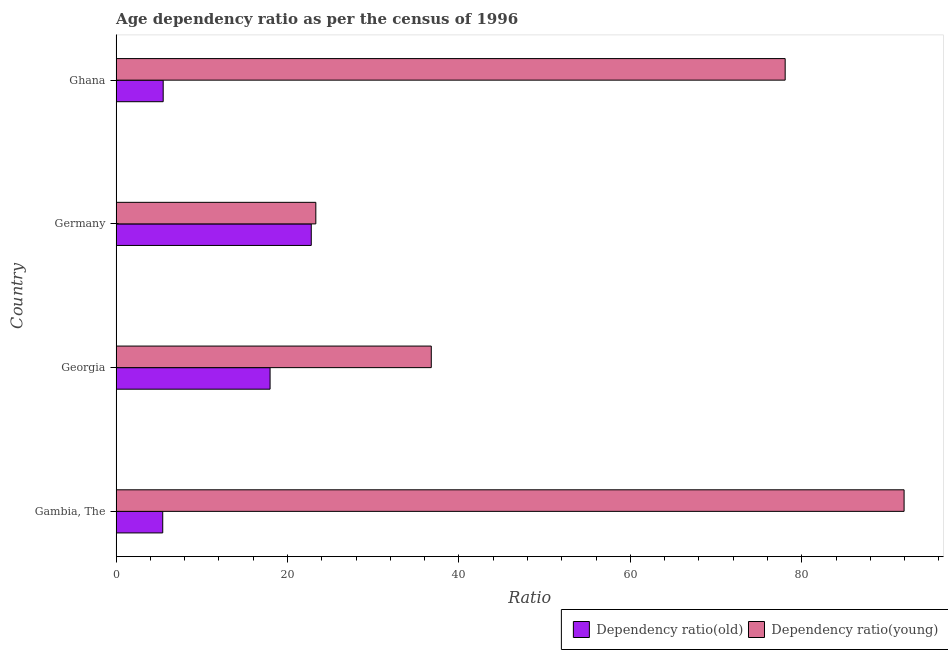How many groups of bars are there?
Provide a short and direct response. 4. Are the number of bars per tick equal to the number of legend labels?
Offer a terse response. Yes. Are the number of bars on each tick of the Y-axis equal?
Offer a very short reply. Yes. How many bars are there on the 2nd tick from the top?
Your response must be concise. 2. What is the label of the 4th group of bars from the top?
Ensure brevity in your answer.  Gambia, The. In how many cases, is the number of bars for a given country not equal to the number of legend labels?
Your response must be concise. 0. What is the age dependency ratio(old) in Ghana?
Your answer should be very brief. 5.49. Across all countries, what is the maximum age dependency ratio(old)?
Ensure brevity in your answer.  22.77. Across all countries, what is the minimum age dependency ratio(young)?
Your response must be concise. 23.3. In which country was the age dependency ratio(old) maximum?
Provide a short and direct response. Germany. In which country was the age dependency ratio(old) minimum?
Offer a very short reply. Gambia, The. What is the total age dependency ratio(young) in the graph?
Your response must be concise. 230.05. What is the difference between the age dependency ratio(old) in Gambia, The and that in Ghana?
Offer a very short reply. -0.05. What is the difference between the age dependency ratio(old) in Gambia, The and the age dependency ratio(young) in Germany?
Your response must be concise. -17.86. What is the average age dependency ratio(old) per country?
Offer a terse response. 12.91. What is the difference between the age dependency ratio(old) and age dependency ratio(young) in Germany?
Your response must be concise. -0.53. In how many countries, is the age dependency ratio(young) greater than 60 ?
Provide a short and direct response. 2. What is the ratio of the age dependency ratio(young) in Germany to that in Ghana?
Offer a terse response. 0.3. What is the difference between the highest and the second highest age dependency ratio(young)?
Your answer should be very brief. 13.87. What is the difference between the highest and the lowest age dependency ratio(old)?
Your answer should be very brief. 17.33. Is the sum of the age dependency ratio(old) in Germany and Ghana greater than the maximum age dependency ratio(young) across all countries?
Keep it short and to the point. No. What does the 2nd bar from the top in Ghana represents?
Provide a succinct answer. Dependency ratio(old). What does the 1st bar from the bottom in Gambia, The represents?
Your answer should be very brief. Dependency ratio(old). Are all the bars in the graph horizontal?
Give a very brief answer. Yes. What is the difference between two consecutive major ticks on the X-axis?
Keep it short and to the point. 20. Are the values on the major ticks of X-axis written in scientific E-notation?
Keep it short and to the point. No. Does the graph contain grids?
Provide a succinct answer. No. Where does the legend appear in the graph?
Your response must be concise. Bottom right. How many legend labels are there?
Provide a short and direct response. 2. What is the title of the graph?
Give a very brief answer. Age dependency ratio as per the census of 1996. Does "GDP per capita" appear as one of the legend labels in the graph?
Your answer should be very brief. No. What is the label or title of the X-axis?
Offer a very short reply. Ratio. What is the Ratio in Dependency ratio(old) in Gambia, The?
Provide a succinct answer. 5.44. What is the Ratio of Dependency ratio(young) in Gambia, The?
Your response must be concise. 91.93. What is the Ratio of Dependency ratio(old) in Georgia?
Offer a very short reply. 17.96. What is the Ratio in Dependency ratio(young) in Georgia?
Offer a terse response. 36.77. What is the Ratio of Dependency ratio(old) in Germany?
Your answer should be very brief. 22.77. What is the Ratio of Dependency ratio(young) in Germany?
Offer a terse response. 23.3. What is the Ratio of Dependency ratio(old) in Ghana?
Your answer should be very brief. 5.49. What is the Ratio in Dependency ratio(young) in Ghana?
Provide a short and direct response. 78.06. Across all countries, what is the maximum Ratio in Dependency ratio(old)?
Make the answer very short. 22.77. Across all countries, what is the maximum Ratio in Dependency ratio(young)?
Your answer should be very brief. 91.93. Across all countries, what is the minimum Ratio in Dependency ratio(old)?
Offer a terse response. 5.44. Across all countries, what is the minimum Ratio of Dependency ratio(young)?
Give a very brief answer. 23.3. What is the total Ratio of Dependency ratio(old) in the graph?
Your answer should be very brief. 51.66. What is the total Ratio of Dependency ratio(young) in the graph?
Offer a very short reply. 230.05. What is the difference between the Ratio of Dependency ratio(old) in Gambia, The and that in Georgia?
Provide a short and direct response. -12.52. What is the difference between the Ratio of Dependency ratio(young) in Gambia, The and that in Georgia?
Provide a short and direct response. 55.16. What is the difference between the Ratio in Dependency ratio(old) in Gambia, The and that in Germany?
Give a very brief answer. -17.33. What is the difference between the Ratio in Dependency ratio(young) in Gambia, The and that in Germany?
Provide a short and direct response. 68.63. What is the difference between the Ratio in Dependency ratio(old) in Gambia, The and that in Ghana?
Provide a succinct answer. -0.05. What is the difference between the Ratio in Dependency ratio(young) in Gambia, The and that in Ghana?
Provide a short and direct response. 13.87. What is the difference between the Ratio of Dependency ratio(old) in Georgia and that in Germany?
Give a very brief answer. -4.8. What is the difference between the Ratio in Dependency ratio(young) in Georgia and that in Germany?
Your answer should be very brief. 13.47. What is the difference between the Ratio in Dependency ratio(old) in Georgia and that in Ghana?
Offer a terse response. 12.47. What is the difference between the Ratio in Dependency ratio(young) in Georgia and that in Ghana?
Offer a very short reply. -41.29. What is the difference between the Ratio in Dependency ratio(old) in Germany and that in Ghana?
Offer a very short reply. 17.27. What is the difference between the Ratio of Dependency ratio(young) in Germany and that in Ghana?
Your answer should be compact. -54.76. What is the difference between the Ratio of Dependency ratio(old) in Gambia, The and the Ratio of Dependency ratio(young) in Georgia?
Keep it short and to the point. -31.33. What is the difference between the Ratio of Dependency ratio(old) in Gambia, The and the Ratio of Dependency ratio(young) in Germany?
Offer a terse response. -17.86. What is the difference between the Ratio of Dependency ratio(old) in Gambia, The and the Ratio of Dependency ratio(young) in Ghana?
Provide a succinct answer. -72.62. What is the difference between the Ratio in Dependency ratio(old) in Georgia and the Ratio in Dependency ratio(young) in Germany?
Offer a very short reply. -5.34. What is the difference between the Ratio in Dependency ratio(old) in Georgia and the Ratio in Dependency ratio(young) in Ghana?
Your answer should be very brief. -60.09. What is the difference between the Ratio of Dependency ratio(old) in Germany and the Ratio of Dependency ratio(young) in Ghana?
Your response must be concise. -55.29. What is the average Ratio in Dependency ratio(old) per country?
Give a very brief answer. 12.91. What is the average Ratio in Dependency ratio(young) per country?
Make the answer very short. 57.51. What is the difference between the Ratio of Dependency ratio(old) and Ratio of Dependency ratio(young) in Gambia, The?
Make the answer very short. -86.49. What is the difference between the Ratio of Dependency ratio(old) and Ratio of Dependency ratio(young) in Georgia?
Provide a succinct answer. -18.81. What is the difference between the Ratio in Dependency ratio(old) and Ratio in Dependency ratio(young) in Germany?
Ensure brevity in your answer.  -0.53. What is the difference between the Ratio of Dependency ratio(old) and Ratio of Dependency ratio(young) in Ghana?
Offer a terse response. -72.57. What is the ratio of the Ratio in Dependency ratio(old) in Gambia, The to that in Georgia?
Your response must be concise. 0.3. What is the ratio of the Ratio in Dependency ratio(young) in Gambia, The to that in Georgia?
Your answer should be very brief. 2.5. What is the ratio of the Ratio of Dependency ratio(old) in Gambia, The to that in Germany?
Provide a succinct answer. 0.24. What is the ratio of the Ratio in Dependency ratio(young) in Gambia, The to that in Germany?
Make the answer very short. 3.95. What is the ratio of the Ratio in Dependency ratio(young) in Gambia, The to that in Ghana?
Provide a succinct answer. 1.18. What is the ratio of the Ratio of Dependency ratio(old) in Georgia to that in Germany?
Give a very brief answer. 0.79. What is the ratio of the Ratio in Dependency ratio(young) in Georgia to that in Germany?
Give a very brief answer. 1.58. What is the ratio of the Ratio in Dependency ratio(old) in Georgia to that in Ghana?
Your response must be concise. 3.27. What is the ratio of the Ratio of Dependency ratio(young) in Georgia to that in Ghana?
Your response must be concise. 0.47. What is the ratio of the Ratio in Dependency ratio(old) in Germany to that in Ghana?
Provide a succinct answer. 4.15. What is the ratio of the Ratio in Dependency ratio(young) in Germany to that in Ghana?
Give a very brief answer. 0.3. What is the difference between the highest and the second highest Ratio of Dependency ratio(old)?
Provide a succinct answer. 4.8. What is the difference between the highest and the second highest Ratio in Dependency ratio(young)?
Give a very brief answer. 13.87. What is the difference between the highest and the lowest Ratio of Dependency ratio(old)?
Offer a very short reply. 17.33. What is the difference between the highest and the lowest Ratio in Dependency ratio(young)?
Your answer should be very brief. 68.63. 